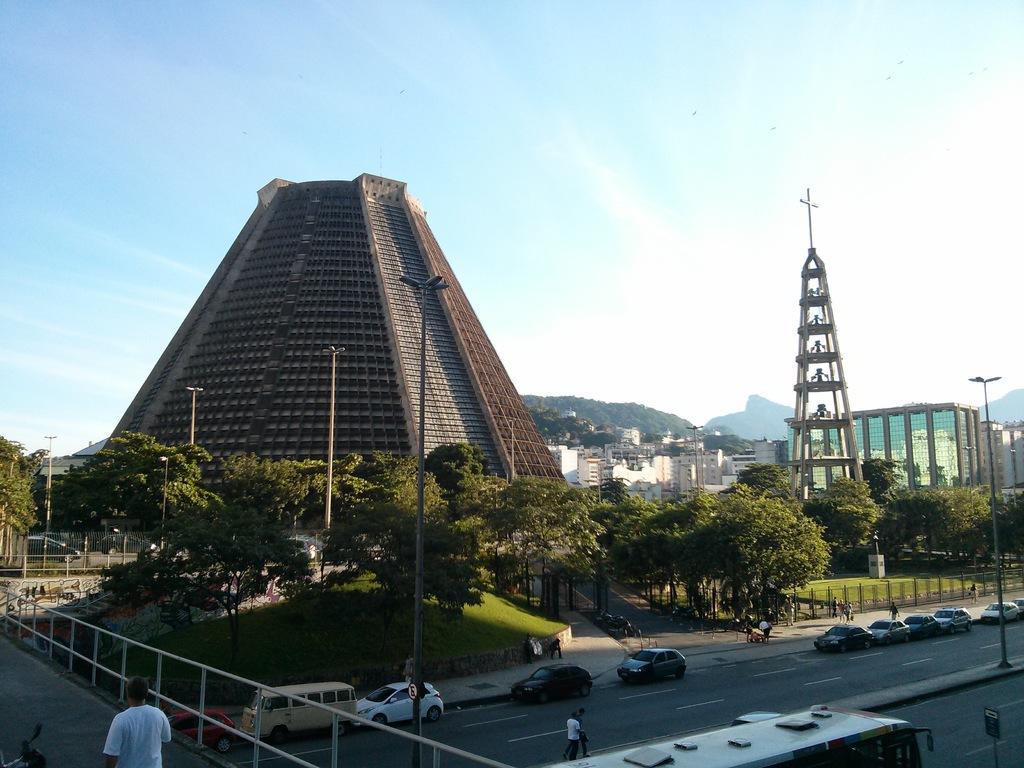How would you summarize this image in a sentence or two? This picture is clicked outside the city. At the bottom of the picture, we see a man in white T-shirt is walking on the bridge. Beside him, we see a railing. In the middle of the picture, we see vehicles are moving on the road and we even see street lights. There are trees, grass, railing and street lights. There are buildings, trees and hills in the background. At the top of the picture, we see the sky. 